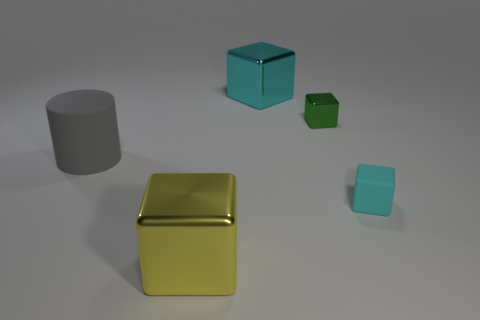Subtract all shiny blocks. How many blocks are left? 1 Subtract all green blocks. How many blocks are left? 3 Subtract all cylinders. How many objects are left? 4 Subtract all yellow cylinders. Subtract all yellow spheres. How many cylinders are left? 1 Subtract all green things. Subtract all blocks. How many objects are left? 0 Add 5 yellow metal objects. How many yellow metal objects are left? 6 Add 3 big yellow things. How many big yellow things exist? 4 Add 4 tiny purple matte spheres. How many objects exist? 9 Subtract 0 brown cylinders. How many objects are left? 5 Subtract 1 blocks. How many blocks are left? 3 